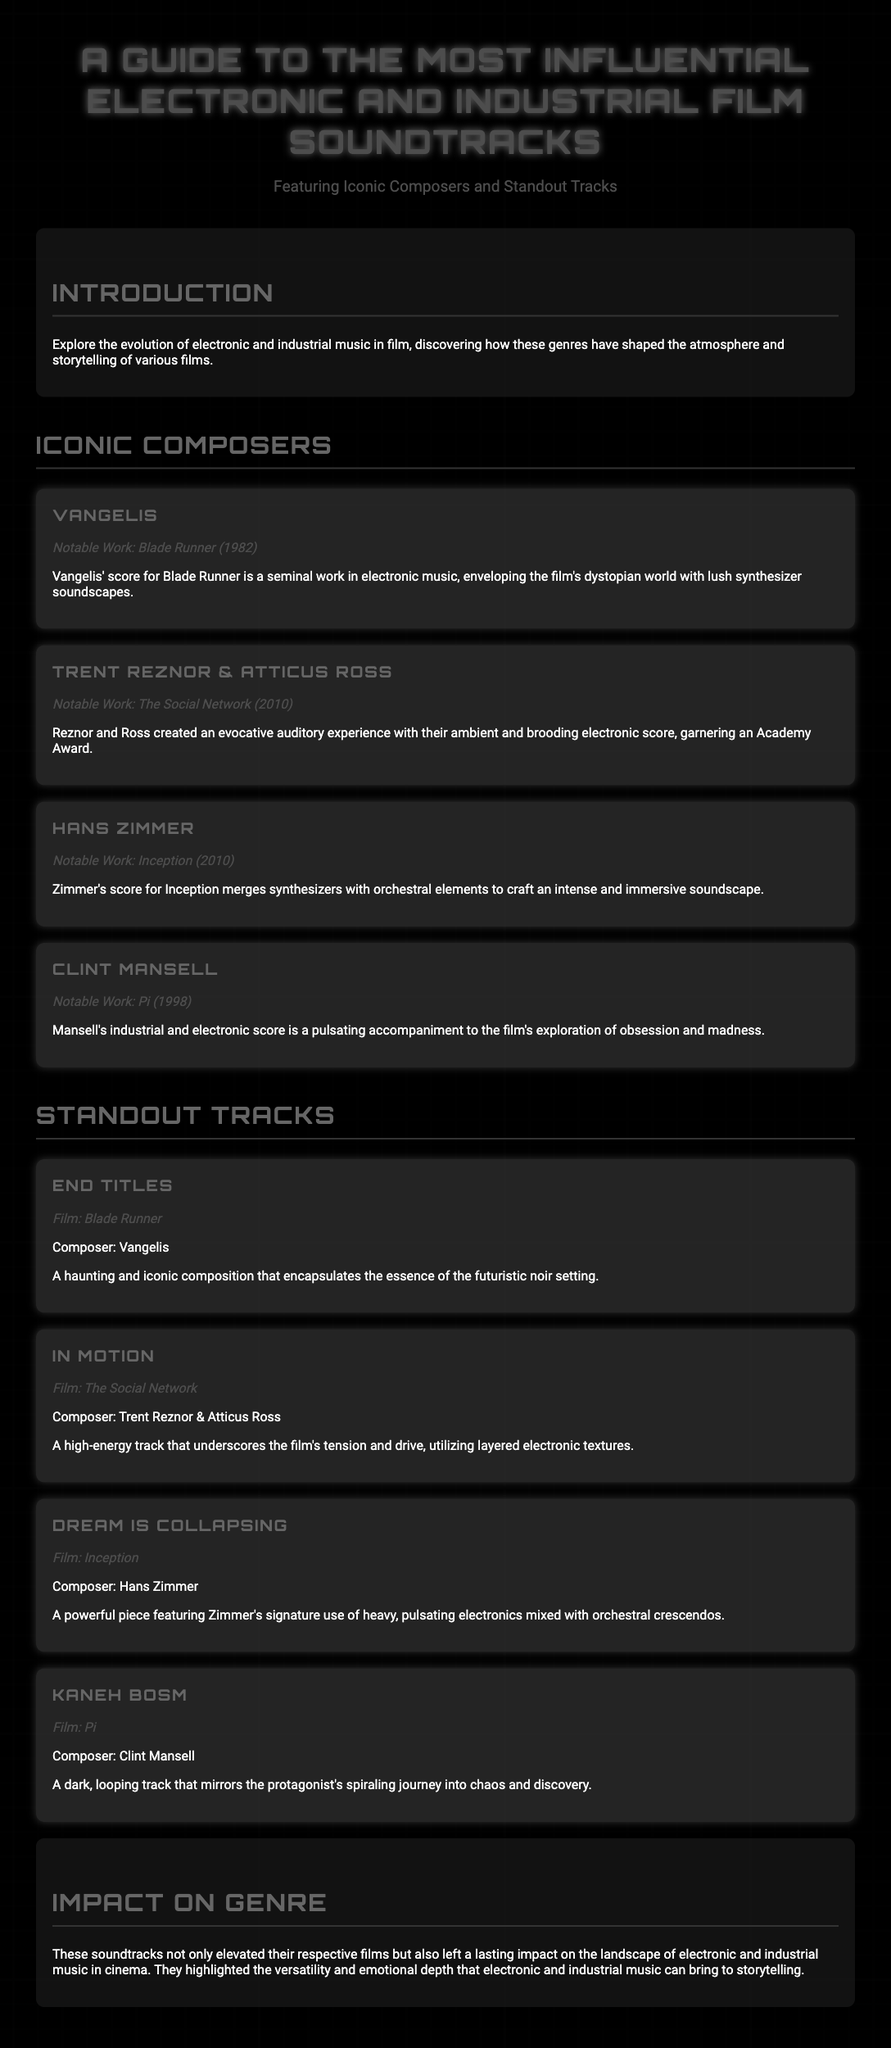What are the featured genres in the guide? The guide focuses on electronic and industrial music.
Answer: Electronic and Industrial Who composed the score for Blade Runner? The section on iconic composers states Vangelis composed the score for Blade Runner.
Answer: Vangelis Which track is associated with The Social Network? The standout tracks section lists "In Motion" as the track for The Social Network.
Answer: In Motion What year was Pi released? The document states that Pi was released in 1998.
Answer: 1998 What is one notable work by Hans Zimmer? The guide mentions "Inception" as a notable work by Hans Zimmer.
Answer: Inception Which composer won an Academy Award for their work? The composers' section highlights that Trent Reznor & Atticus Ross won an Academy Award.
Answer: Trent Reznor & Atticus Ross What kind of impact did these soundtracks have? The impact section describes the lasting impact on the landscape of electronic and industrial music in cinema.
Answer: Lasting impact What is the subtitle of the guide? The subtitle clearly states "Featuring Iconic Composers and Standout Tracks."
Answer: Featuring Iconic Composers and Standout Tracks Which track is described as powerful and heavy? The description for "Dream is Collapsing" indicates it features heavy and pulsating electronics.
Answer: Dream is Collapsing 